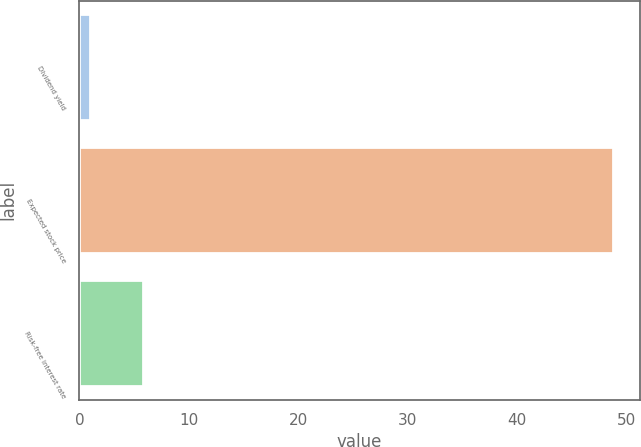<chart> <loc_0><loc_0><loc_500><loc_500><bar_chart><fcel>Dividend yield<fcel>Expected stock price<fcel>Risk-free interest rate<nl><fcel>1<fcel>48.8<fcel>5.78<nl></chart> 